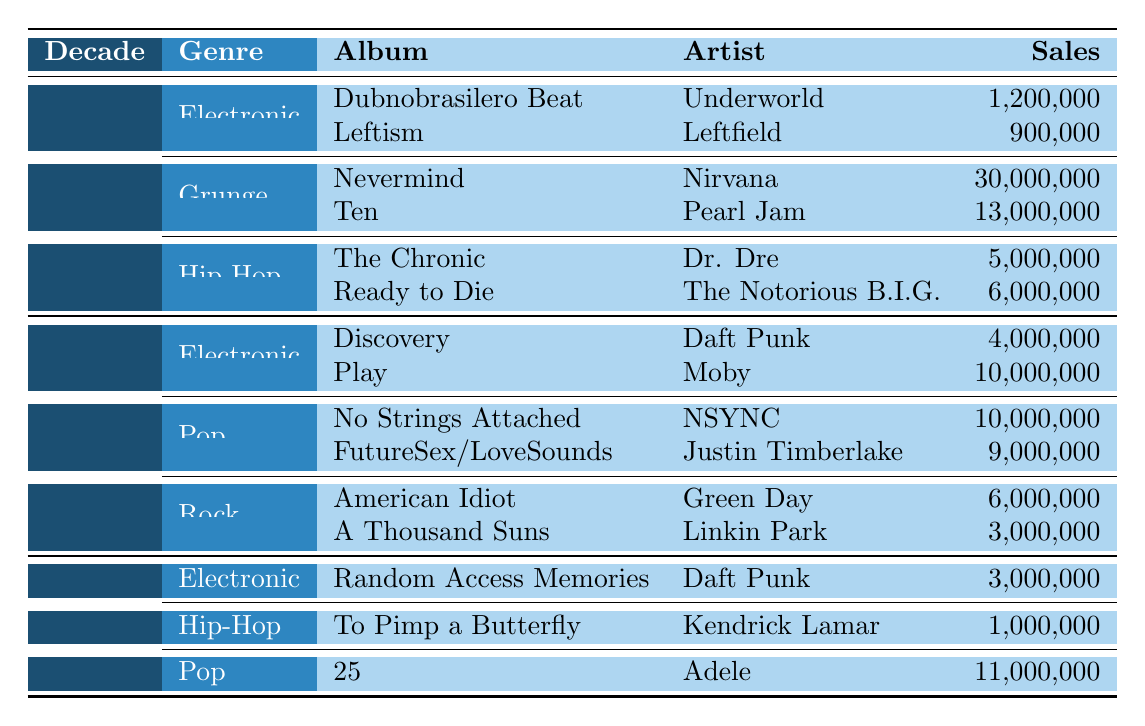What was the best-selling album in the 1990s? Referring to the table, "Nevermind" by Nirvana has the highest sales at 30,000,000, which is greater than any other album listed for that decade.
Answer: Nevermind How many albums by Underworld are listed in the table? There is one album by Underworld listed, which is "Dubnobrasilero Beat" under the Electronic genre in the 1990s.
Answer: One Which genre had the highest sales in the 2000s? In the 2000s, the Pop genre had cumulative sales of 19,000,000 (10,000,000 for "No Strings Attached" and 9,000,000 for "FutureSex/LoveSounds"), which is higher than sales from the Electronic and Rock genres.
Answer: Pop What is the total sales of Electronic albums across all decades? The total sales of Electronic albums is calculated by adding the sales: 1,200,000 (1990s) + 4,000,000 (2000s) + 3,000,000 (2010s) = 8,200,000.
Answer: 8,200,000 Was "To Pimp a Butterfly" by Kendrick Lamar the only Hip-Hop album listed? Yes, the table shows that "To Pimp a Butterfly" is the only Hip-Hop album listed in the 2010s, indicating there are no others in that decade within the displayed data.
Answer: Yes Which decade had the lowest total sales for albums listed in the table? The 2010s had the lowest sales totaling 15,000,000 (3,000,000 from Electronic, 1,000,000 from Hip-Hop, and 11,000,000 from Pop), lower than any totals for the 1990s or 2000s.
Answer: 2010s What was the difference in album sales between "The Chronic" and "Ready to Die"? The difference in sales is calculated as 6,000,000 (for "Ready to Die") - 5,000,000 (for "The Chronic") = 1,000,000.
Answer: 1,000,000 Is "American Idiot" by Green Day listed as the best-selling album in the 2000s? No, "American Idiot" has sales of 6,000,000 which is less than "Play" by Moby and "Discovery" by Daft Punk.
Answer: No Which artist had the highest sales among the albums listed in the 1990s? Nirvana with "Nevermind" had the highest sales, totaling 30,000,000, which surpasses any other album's sales in that decade.
Answer: Nirvana 